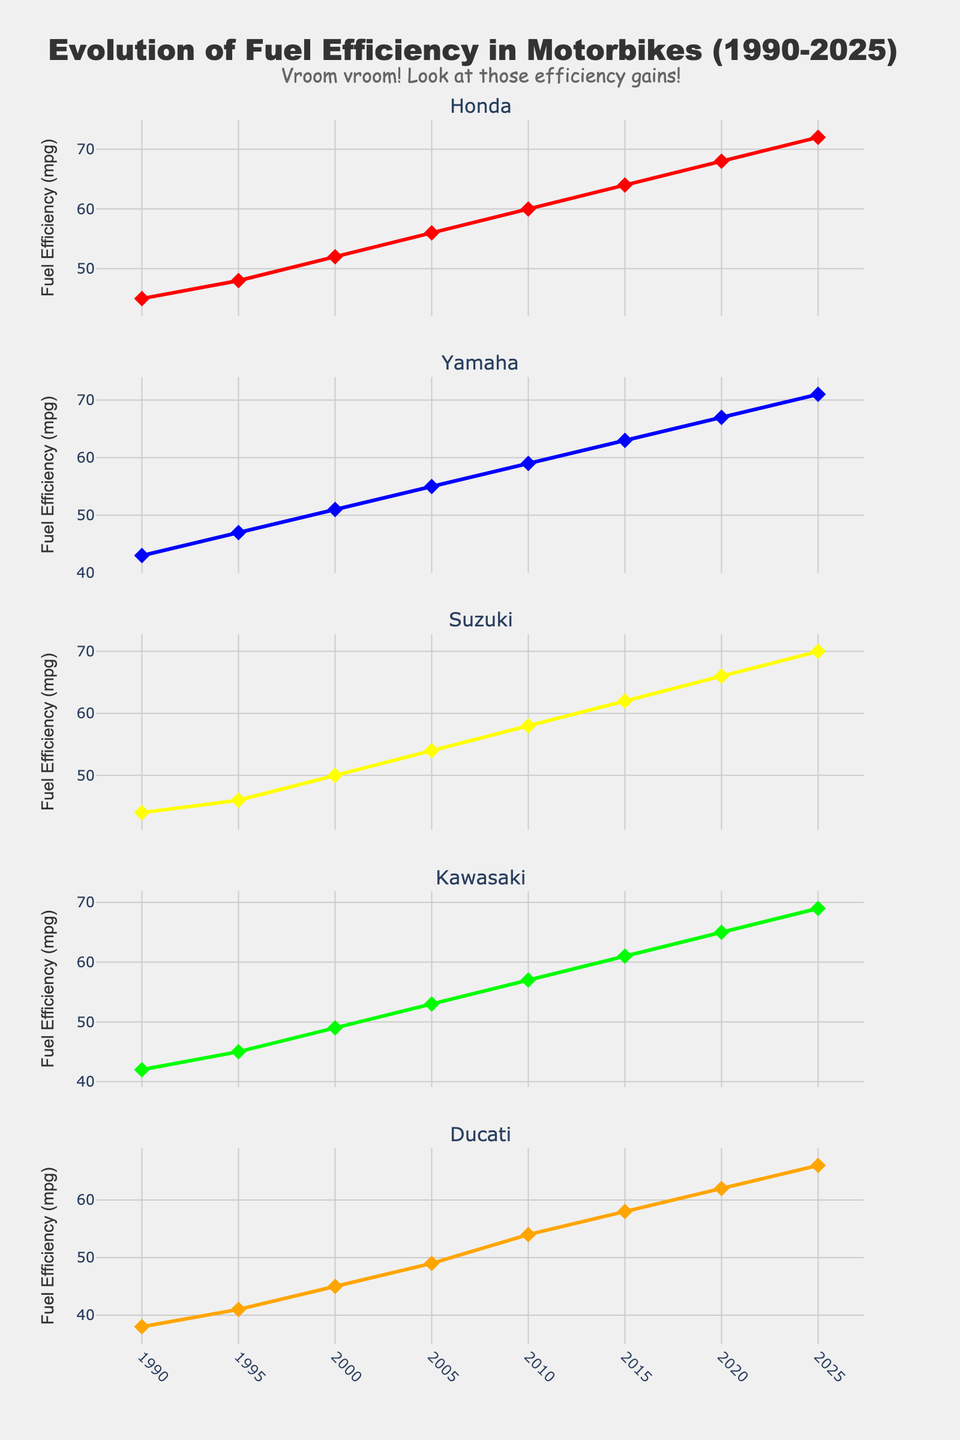What is the title of the figure? The title of the figure is prominently displayed at the top, reading "Evolution of Fuel Efficiency in Motorbikes (1990-2025)".
Answer: Evolution of Fuel Efficiency in Motorbikes (1990-2025) Which manufacturer’s subplot has the steepest increase in fuel efficiency over the years? By observing the slopes of the lines in each subplot, Ducati's subplot shows the steepest increase in fuel efficiency from 38 mpg in 1990 to 66 mpg in 2025.
Answer: Ducati What is the fuel efficiency of Yamaha in 2020? Refer to the Yamaha subplot and locate the data point for the year 2020, where the value is 67 mpg.
Answer: 67 mpg Did Honda ever have the lowest fuel efficiency among the manufacturers in any given year? By comparing the fuel efficiency across all subplots for each year, Honda never has the lowest value; Ducati often has the lowest values.
Answer: No By how much did Suzuki’s fuel efficiency increase from 1990 to 2010? Suzuki's fuel efficiency in 1990 was 44 mpg, and by 2010 it was 58 mpg. The increase is calculated as 58 - 44 = 14 mpg.
Answer: 14 mpg Which manufacturer showed the smallest improvement in fuel efficiency from 1990 to 2025? Calculate the improvements for each manufacturer. Ducati improved from 38 mpg to 66 mpg, a 28 mpg improvement, which is smaller compared to other manufacturers.
Answer: Ducati Compare the fuel efficiency of Honda and Kawasaki in 1995. Which one was higher, and by how much? For 1995, Honda's efficiency was 48 mpg and Kawasaki's was 45 mpg; hence, Honda’s was higher by 48 - 45 = 3 mpg.
Answer: Honda by 3 mpg What can you say about the trend in motorbike fuel efficiency from 1990 to 2025? All manufacturers exhibit a consistent upward trend in fuel efficiency, indicating continual improvements over the years.
Answer: Consistent upward trend Considering the vertical subplots, which manufacturer had the highest fuel efficiency in 2005? By examining each subplot for the 2005 data points, Honda had the highest fuel efficiency at 56 mpg.
Answer: Honda 